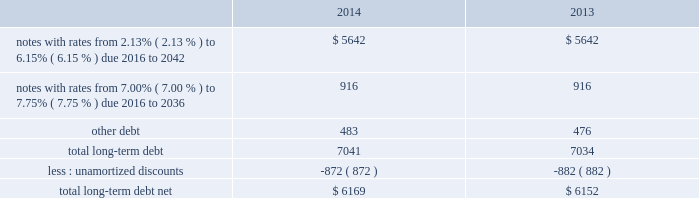As of december 31 , 2014 and 2013 , our liabilities associated with unrecognized tax benefits are not material .
We and our subsidiaries file income tax returns in the u.s .
Federal jurisdiction and various foreign jurisdictions .
With few exceptions , the statute of limitations is no longer open for u.s .
Federal or non-u.s .
Income tax examinations for the years before 2011 , other than with respect to refunds .
U.s .
Income taxes and foreign withholding taxes have not been provided on earnings of $ 291 million , $ 222 million and $ 211 million that have not been distributed by our non-u.s .
Companies as of december 31 , 2014 , 2013 and 2012 .
Our intention is to permanently reinvest these earnings , thereby indefinitely postponing their remittance to the u.s .
If these earnings had been remitted , we estimate that the additional income taxes after foreign tax credits would have been approximately $ 55 million in 2014 , $ 50 million in 2013 and $ 45 million in 2012 .
Our federal and foreign income tax payments , net of refunds received , were $ 1.5 billion in 2014 , $ 787 million in 2013 and $ 890 million in 2012 .
Our 2014 and 2013 net payments reflect a $ 200 million and $ 550 million refund from the irs primarily attributable to our tax-deductible discretionary pension contributions during the fourth quarters of 2013 and 2012 , and our 2012 net payments reflect a $ 153 million refund from the irs related to a 2011 capital loss carryback .
Note 8 2013 debt our long-term debt consisted of the following ( in millions ) : .
In august 2014 , we entered into a new $ 1.5 billion revolving credit facility with a syndicate of banks and concurrently terminated our existing $ 1.5 billion revolving credit facility which was scheduled to expire in august 2016 .
The new credit facility expires august 2019 and we may request and the banks may grant , at their discretion , an increase to the new credit facility of up to an additional $ 500 million .
The credit facility also includes a sublimit of up to $ 300 million available for the issuance of letters of credit .
There were no borrowings outstanding under the new facility through december 31 , 2014 .
Borrowings under the new credit facility would be unsecured and bear interest at rates based , at our option , on a eurodollar rate or a base rate , as defined in the new credit facility .
Each bank 2019s obligation to make loans under the credit facility is subject to , among other things , our compliance with various representations , warranties and covenants , including covenants limiting our ability and certain of our subsidiaries 2019 ability to encumber assets and a covenant not to exceed a maximum leverage ratio , as defined in the credit facility .
The leverage ratio covenant excludes the adjustments recognized in stockholders 2019 equity related to postretirement benefit plans .
As of december 31 , 2014 , we were in compliance with all covenants contained in the credit facility , as well as in our debt agreements .
We have agreements in place with financial institutions to provide for the issuance of commercial paper .
There were no commercial paper borrowings outstanding during 2014 or 2013 .
If we were to issue commercial paper , the borrowings would be supported by the credit facility .
In april 2013 , we repaid $ 150 million of long-term notes with a fixed interest rate of 7.38% ( 7.38 % ) due to their scheduled maturities .
During the next five years , we have scheduled long-term debt maturities of $ 952 million due in 2016 and $ 900 million due in 2019 .
Interest payments were $ 326 million in 2014 , $ 340 million in 2013 and $ 378 million in 2012 .
All of our existing unsecured and unsubordinated indebtedness rank equally in right of payment .
Note 9 2013 postretirement plans defined benefit pension plans and retiree medical and life insurance plans many of our employees are covered by qualified defined benefit pension plans and we provide certain health care and life insurance benefits to eligible retirees ( collectively , postretirement benefit plans ) .
We also sponsor nonqualified defined benefit pension plans to provide for benefits in excess of qualified plan limits .
Non-union represented employees hired after december 2005 do not participate in our qualified defined benefit pension plans , but are eligible to participate in a qualified .
What was the change in millions of total long-term debt net between 2013 and 2014? 
Computations: (6169 - 6152)
Answer: 17.0. As of december 31 , 2014 and 2013 , our liabilities associated with unrecognized tax benefits are not material .
We and our subsidiaries file income tax returns in the u.s .
Federal jurisdiction and various foreign jurisdictions .
With few exceptions , the statute of limitations is no longer open for u.s .
Federal or non-u.s .
Income tax examinations for the years before 2011 , other than with respect to refunds .
U.s .
Income taxes and foreign withholding taxes have not been provided on earnings of $ 291 million , $ 222 million and $ 211 million that have not been distributed by our non-u.s .
Companies as of december 31 , 2014 , 2013 and 2012 .
Our intention is to permanently reinvest these earnings , thereby indefinitely postponing their remittance to the u.s .
If these earnings had been remitted , we estimate that the additional income taxes after foreign tax credits would have been approximately $ 55 million in 2014 , $ 50 million in 2013 and $ 45 million in 2012 .
Our federal and foreign income tax payments , net of refunds received , were $ 1.5 billion in 2014 , $ 787 million in 2013 and $ 890 million in 2012 .
Our 2014 and 2013 net payments reflect a $ 200 million and $ 550 million refund from the irs primarily attributable to our tax-deductible discretionary pension contributions during the fourth quarters of 2013 and 2012 , and our 2012 net payments reflect a $ 153 million refund from the irs related to a 2011 capital loss carryback .
Note 8 2013 debt our long-term debt consisted of the following ( in millions ) : .
In august 2014 , we entered into a new $ 1.5 billion revolving credit facility with a syndicate of banks and concurrently terminated our existing $ 1.5 billion revolving credit facility which was scheduled to expire in august 2016 .
The new credit facility expires august 2019 and we may request and the banks may grant , at their discretion , an increase to the new credit facility of up to an additional $ 500 million .
The credit facility also includes a sublimit of up to $ 300 million available for the issuance of letters of credit .
There were no borrowings outstanding under the new facility through december 31 , 2014 .
Borrowings under the new credit facility would be unsecured and bear interest at rates based , at our option , on a eurodollar rate or a base rate , as defined in the new credit facility .
Each bank 2019s obligation to make loans under the credit facility is subject to , among other things , our compliance with various representations , warranties and covenants , including covenants limiting our ability and certain of our subsidiaries 2019 ability to encumber assets and a covenant not to exceed a maximum leverage ratio , as defined in the credit facility .
The leverage ratio covenant excludes the adjustments recognized in stockholders 2019 equity related to postretirement benefit plans .
As of december 31 , 2014 , we were in compliance with all covenants contained in the credit facility , as well as in our debt agreements .
We have agreements in place with financial institutions to provide for the issuance of commercial paper .
There were no commercial paper borrowings outstanding during 2014 or 2013 .
If we were to issue commercial paper , the borrowings would be supported by the credit facility .
In april 2013 , we repaid $ 150 million of long-term notes with a fixed interest rate of 7.38% ( 7.38 % ) due to their scheduled maturities .
During the next five years , we have scheduled long-term debt maturities of $ 952 million due in 2016 and $ 900 million due in 2019 .
Interest payments were $ 326 million in 2014 , $ 340 million in 2013 and $ 378 million in 2012 .
All of our existing unsecured and unsubordinated indebtedness rank equally in right of payment .
Note 9 2013 postretirement plans defined benefit pension plans and retiree medical and life insurance plans many of our employees are covered by qualified defined benefit pension plans and we provide certain health care and life insurance benefits to eligible retirees ( collectively , postretirement benefit plans ) .
We also sponsor nonqualified defined benefit pension plans to provide for benefits in excess of qualified plan limits .
Non-union represented employees hired after december 2005 do not participate in our qualified defined benefit pension plans , but are eligible to participate in a qualified .
What was the average total long-term debt from 2013 to 2014? 
Computations: ((6169 - 6152) / 2)
Answer: 8.5. 